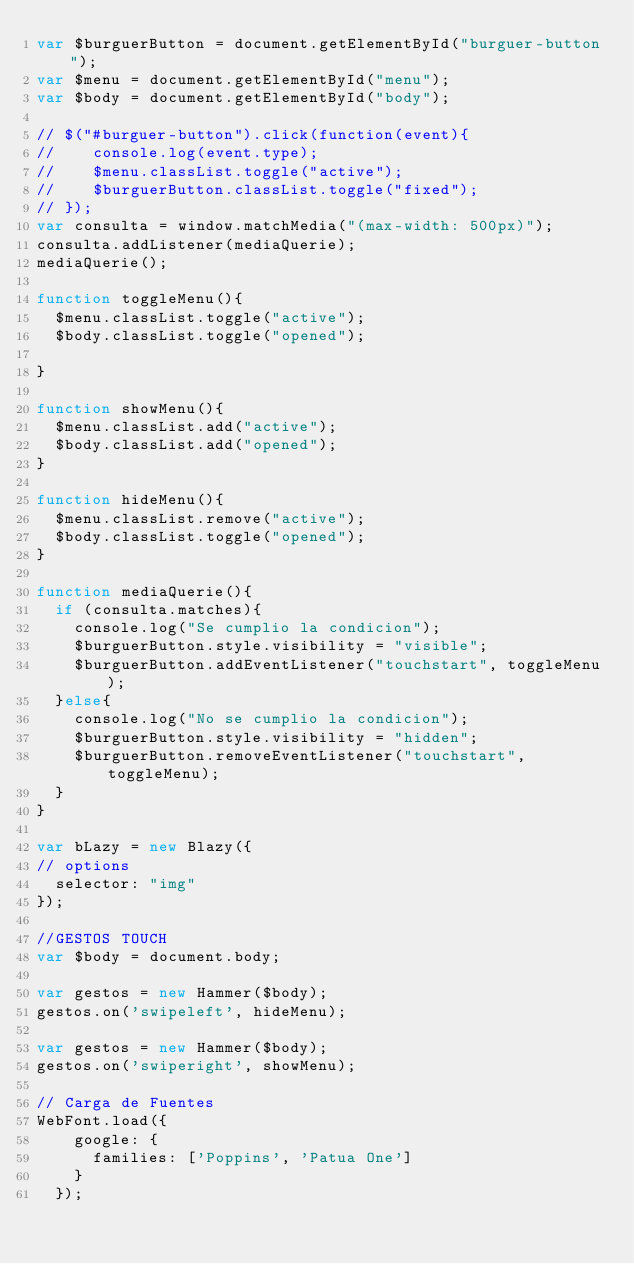<code> <loc_0><loc_0><loc_500><loc_500><_JavaScript_>var $burguerButton = document.getElementById("burguer-button");
var $menu = document.getElementById("menu");
var $body = document.getElementById("body");

// $("#burguer-button").click(function(event){
// 		console.log(event.type);
// 		$menu.classList.toggle("active");
// 		$burguerButton.classList.toggle("fixed");
// });
var consulta = window.matchMedia("(max-width: 500px)");
consulta.addListener(mediaQuerie);
mediaQuerie();

function toggleMenu(){
	$menu.classList.toggle("active");
	$body.classList.toggle("opened");

}

function showMenu(){
	$menu.classList.add("active");
	$body.classList.add("opened");
}

function hideMenu(){
	$menu.classList.remove("active");
	$body.classList.toggle("opened");
}

function mediaQuerie(){
	if (consulta.matches){
		console.log("Se cumplio la condicion");
		$burguerButton.style.visibility = "visible";
		$burguerButton.addEventListener("touchstart", toggleMenu);
	}else{
		console.log("No se cumplio la condicion");
		$burguerButton.style.visibility = "hidden";
		$burguerButton.removeEventListener("touchstart", toggleMenu);
	}
}

var bLazy = new Blazy({
// options
	selector: "img"
});

//GESTOS TOUCH
var $body = document.body;

var gestos = new Hammer($body);
gestos.on('swipeleft', hideMenu); 

var gestos = new Hammer($body);
gestos.on('swiperight', showMenu);

// Carga de Fuentes
WebFont.load({
    google: {
      families: ['Poppins', 'Patua One']
    }
  });</code> 